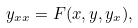Convert formula to latex. <formula><loc_0><loc_0><loc_500><loc_500>y _ { x x } = F ( x , y , y _ { x } ) ,</formula> 